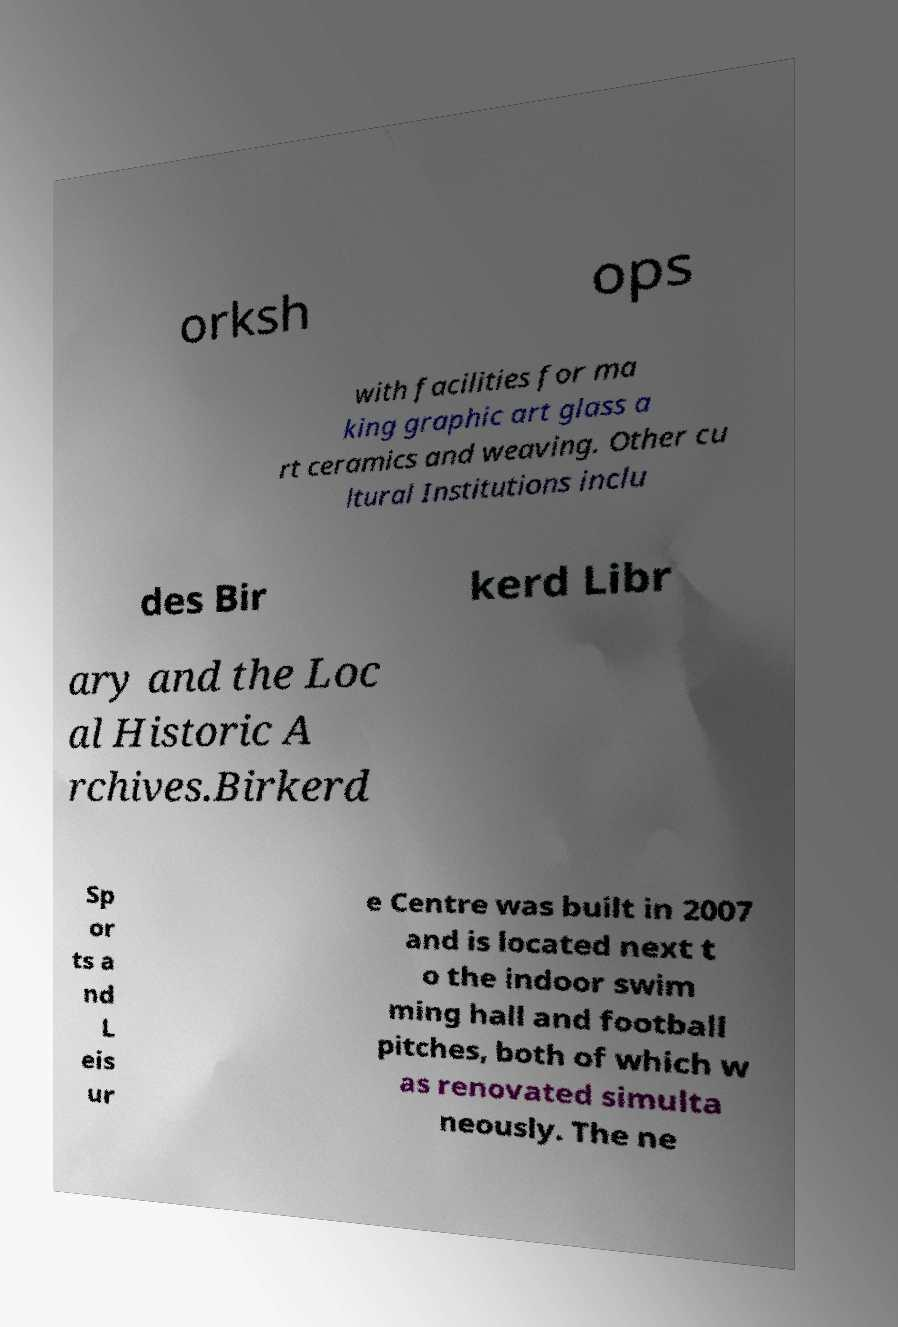Please read and relay the text visible in this image. What does it say? orksh ops with facilities for ma king graphic art glass a rt ceramics and weaving. Other cu ltural Institutions inclu des Bir kerd Libr ary and the Loc al Historic A rchives.Birkerd Sp or ts a nd L eis ur e Centre was built in 2007 and is located next t o the indoor swim ming hall and football pitches, both of which w as renovated simulta neously. The ne 